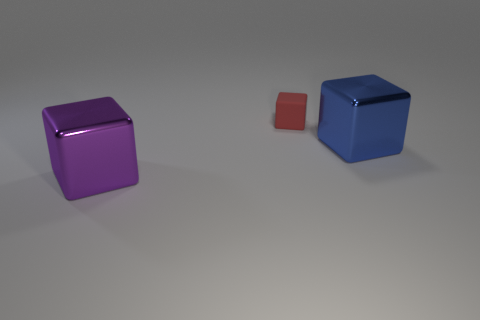There is a tiny red block right of the purple metallic block; what is its material?
Provide a short and direct response. Rubber. There is another tiny object that is the same shape as the blue metallic object; what is its material?
Provide a short and direct response. Rubber. Are there any large cubes that are left of the shiny thing that is on the right side of the matte block?
Make the answer very short. Yes. The other thing that is the same material as the blue object is what shape?
Make the answer very short. Cube. There is a shiny object on the right side of the big purple cube; does it have the same size as the shiny block in front of the large blue object?
Your answer should be very brief. Yes. Are there more red rubber things that are left of the blue block than red rubber blocks right of the tiny thing?
Your response must be concise. Yes. What number of cubes are on the right side of the purple object that is in front of the red cube?
Keep it short and to the point. 2. Is there any other thing that has the same material as the tiny red cube?
Ensure brevity in your answer.  No. The tiny block behind the metallic cube in front of the block to the right of the red rubber object is made of what material?
Keep it short and to the point. Rubber. The cube that is both on the left side of the blue metal object and in front of the small rubber block is made of what material?
Make the answer very short. Metal. 